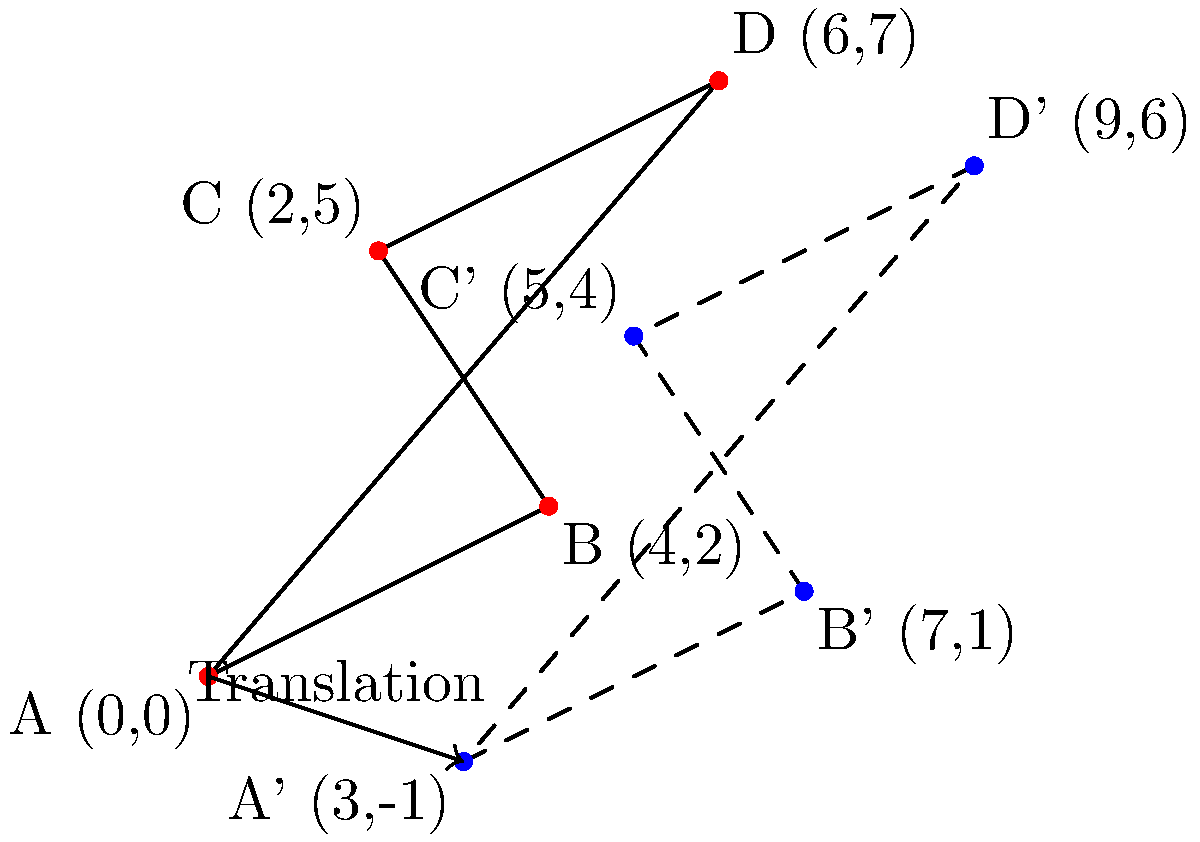A farm structure's GPS coordinates are represented by the red quadrilateral ABCD. Due to a natural disaster, the structure needs to be relocated. The new reference point is obtained by translating all points 3 units to the right and 1 unit down, resulting in the blue dashed quadrilateral A'B'C'D'. If the original coordinates of point C are (2,5), what are the coordinates of point C' after the translation? To solve this problem, we need to apply the given translation to the original coordinates of point C. Here's the step-by-step process:

1. Identify the original coordinates of point C:
   C = (2, 5)

2. Determine the translation vector:
   The question states that all points are translated 3 units to the right and 1 unit down.
   Translation vector = (3, -1)

3. Apply the translation to point C:
   - To translate a point, we add the translation vector to the original coordinates.
   - For the x-coordinate: 2 + 3 = 5
   - For the y-coordinate: 5 + (-1) = 4

4. Therefore, the new coordinates of point C' are:
   C' = (5, 4)

This result can be verified visually in the provided diagram, where C' is labeled as (5,4).
Answer: (5, 4) 